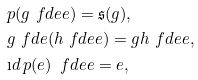<formula> <loc_0><loc_0><loc_500><loc_500>& p ( g \ f d e e ) = { \mathfrak s } ( g ) , & \\ & g \ f d e ( h \ f d e e ) = g h \ f d e e , & \\ & \i d \, { p ( e ) } \, \ f d e e = e , &</formula> 